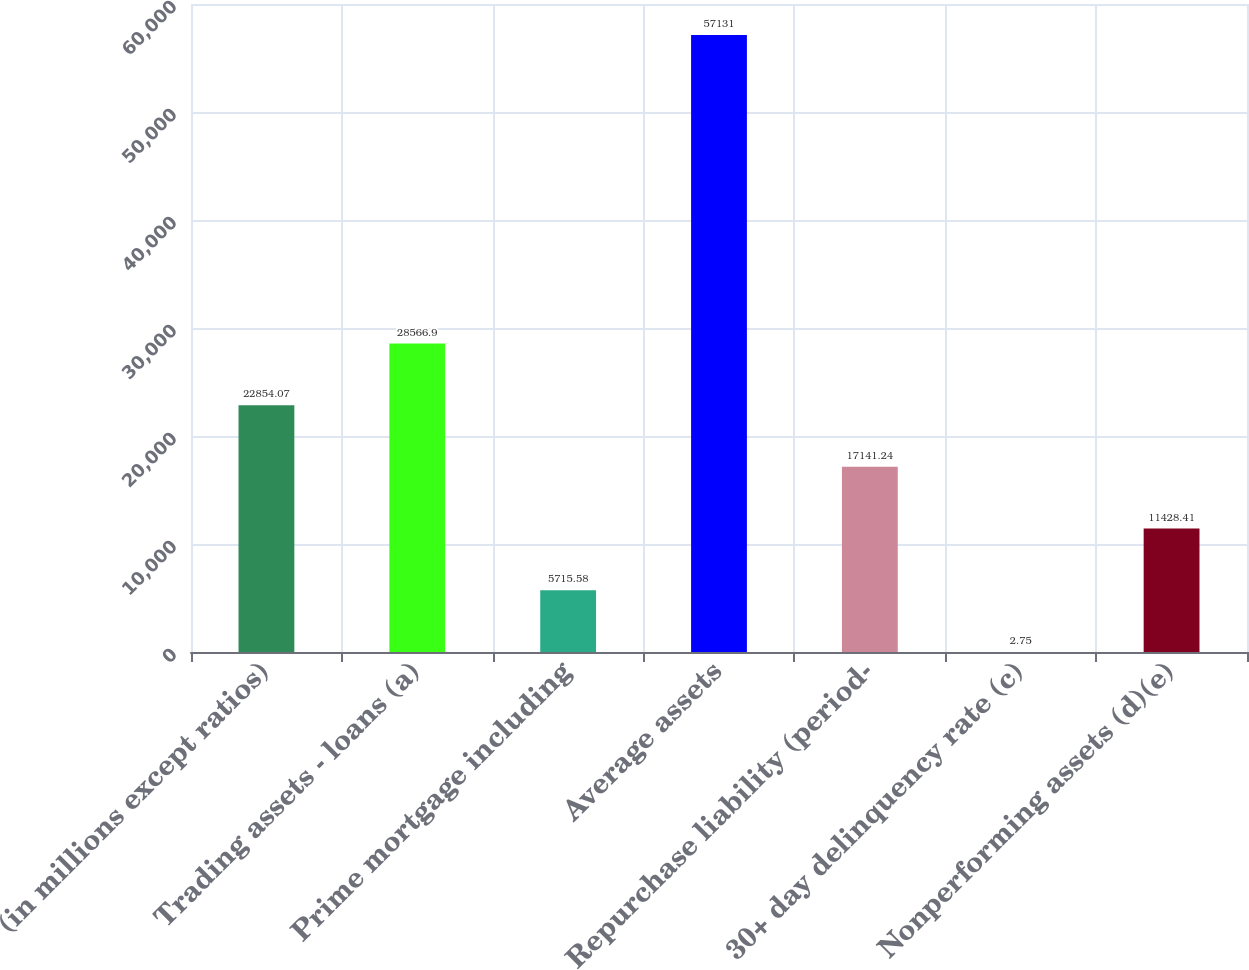Convert chart to OTSL. <chart><loc_0><loc_0><loc_500><loc_500><bar_chart><fcel>(in millions except ratios)<fcel>Trading assets - loans (a)<fcel>Prime mortgage including<fcel>Average assets<fcel>Repurchase liability (period-<fcel>30+ day delinquency rate (c)<fcel>Nonperforming assets (d)(e)<nl><fcel>22854.1<fcel>28566.9<fcel>5715.58<fcel>57131<fcel>17141.2<fcel>2.75<fcel>11428.4<nl></chart> 